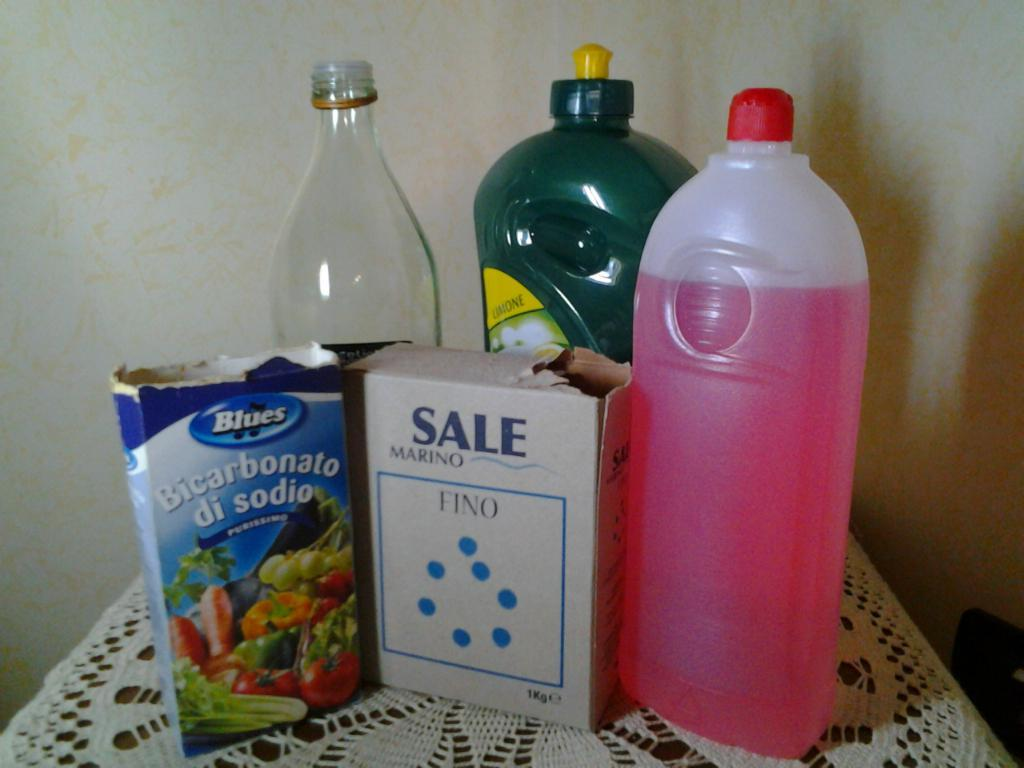Provide a one-sentence caption for the provided image. a white Sale box next to other grocery items. 